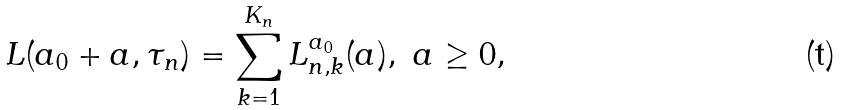<formula> <loc_0><loc_0><loc_500><loc_500>L ( a _ { 0 } + a , \tau _ { n } ) = \sum _ { k = 1 } ^ { K _ { n } } L _ { n , k } ^ { a _ { 0 } } ( a ) , \ a \geq 0 ,</formula> 